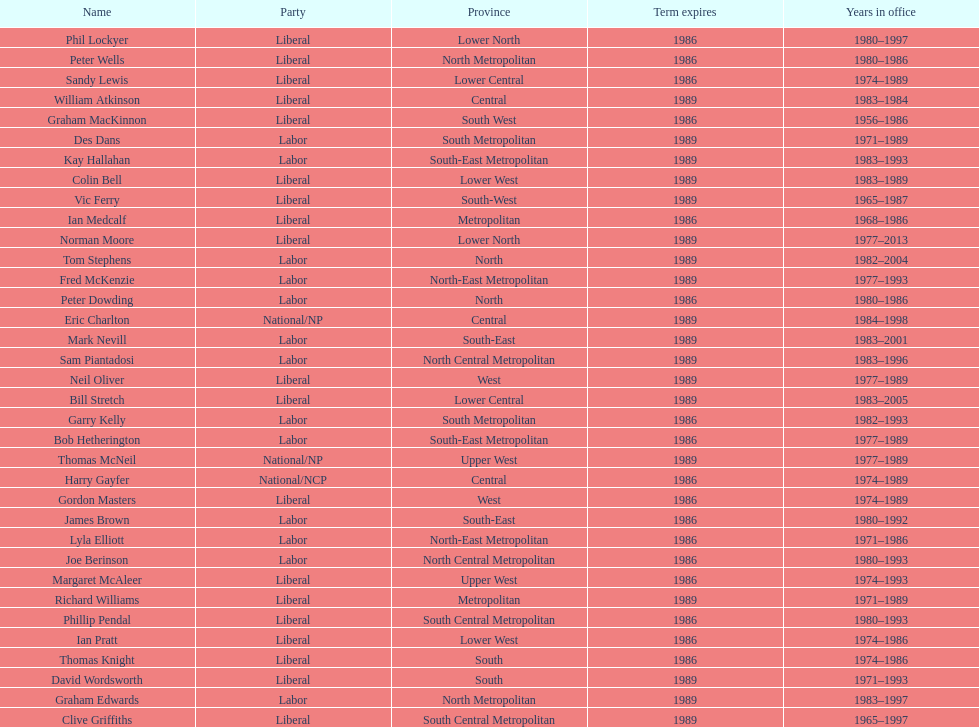What is the number of people in the liberal party? 19. 